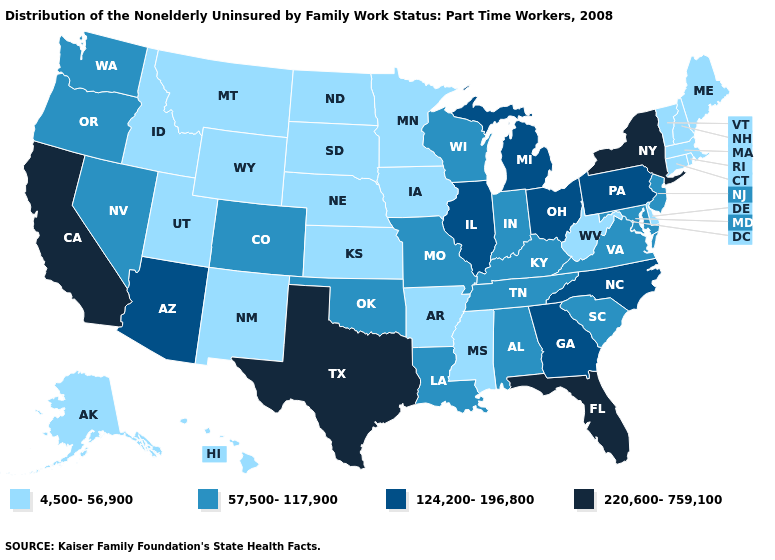Among the states that border Colorado , does Utah have the lowest value?
Be succinct. Yes. Among the states that border Indiana , which have the lowest value?
Answer briefly. Kentucky. Which states have the highest value in the USA?
Be succinct. California, Florida, New York, Texas. What is the value of Montana?
Keep it brief. 4,500-56,900. Does Maine have the same value as Ohio?
Quick response, please. No. Which states have the lowest value in the USA?
Keep it brief. Alaska, Arkansas, Connecticut, Delaware, Hawaii, Idaho, Iowa, Kansas, Maine, Massachusetts, Minnesota, Mississippi, Montana, Nebraska, New Hampshire, New Mexico, North Dakota, Rhode Island, South Dakota, Utah, Vermont, West Virginia, Wyoming. Does Delaware have the lowest value in the South?
Short answer required. Yes. What is the highest value in states that border Idaho?
Keep it brief. 57,500-117,900. Among the states that border Ohio , which have the highest value?
Give a very brief answer. Michigan, Pennsylvania. Does Mississippi have a higher value than Nebraska?
Write a very short answer. No. What is the lowest value in states that border Alabama?
Quick response, please. 4,500-56,900. Does the map have missing data?
Answer briefly. No. Name the states that have a value in the range 57,500-117,900?
Keep it brief. Alabama, Colorado, Indiana, Kentucky, Louisiana, Maryland, Missouri, Nevada, New Jersey, Oklahoma, Oregon, South Carolina, Tennessee, Virginia, Washington, Wisconsin. Name the states that have a value in the range 220,600-759,100?
Short answer required. California, Florida, New York, Texas. What is the highest value in the USA?
Give a very brief answer. 220,600-759,100. 